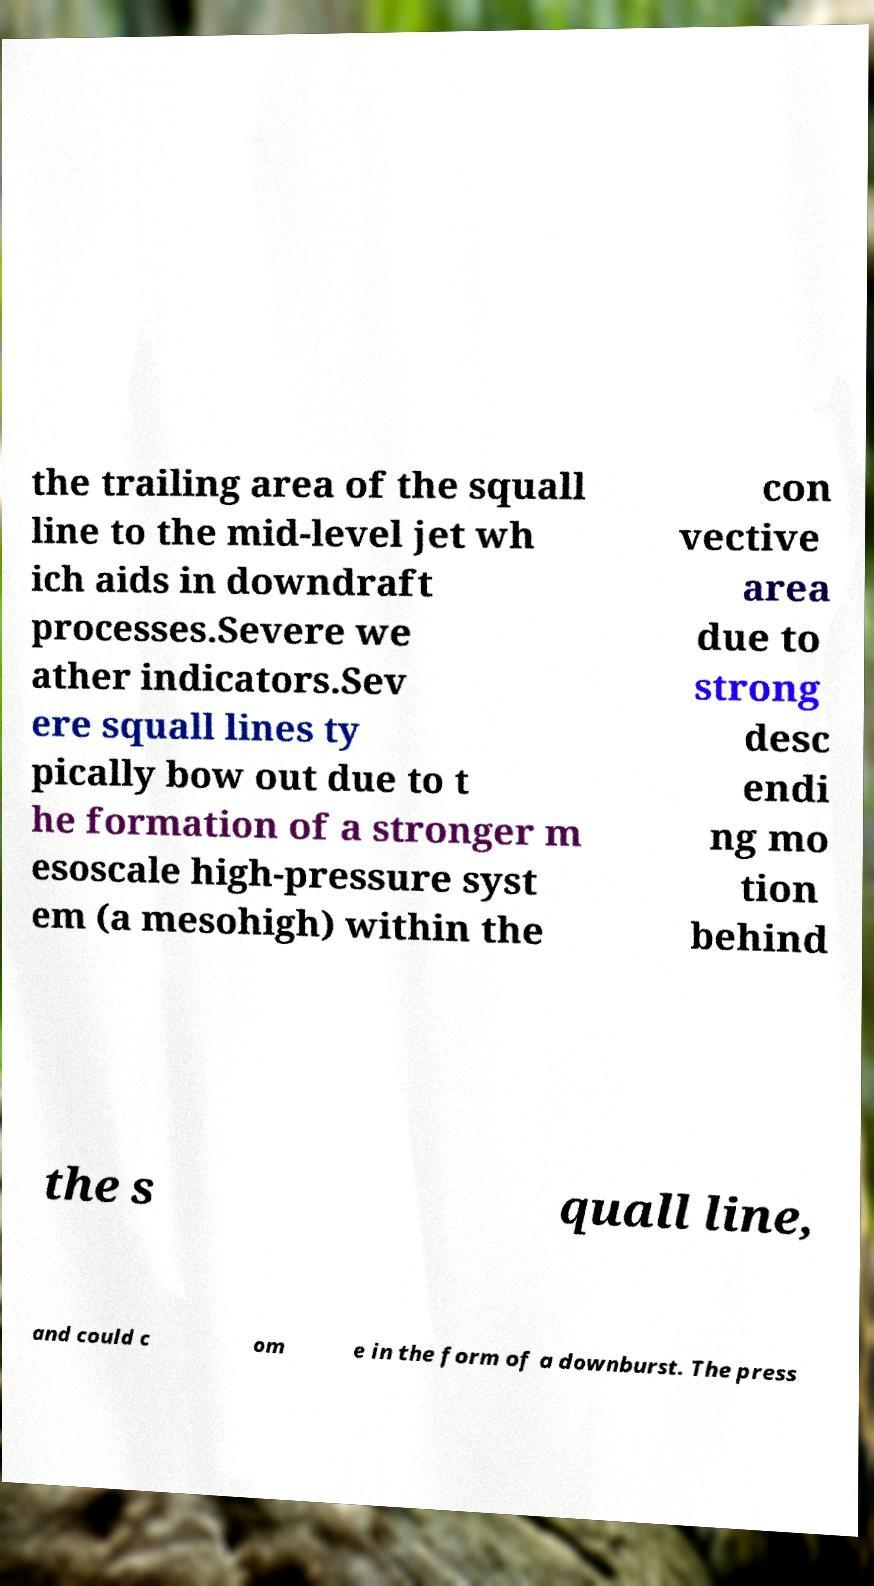Please identify and transcribe the text found in this image. the trailing area of the squall line to the mid-level jet wh ich aids in downdraft processes.Severe we ather indicators.Sev ere squall lines ty pically bow out due to t he formation of a stronger m esoscale high-pressure syst em (a mesohigh) within the con vective area due to strong desc endi ng mo tion behind the s quall line, and could c om e in the form of a downburst. The press 